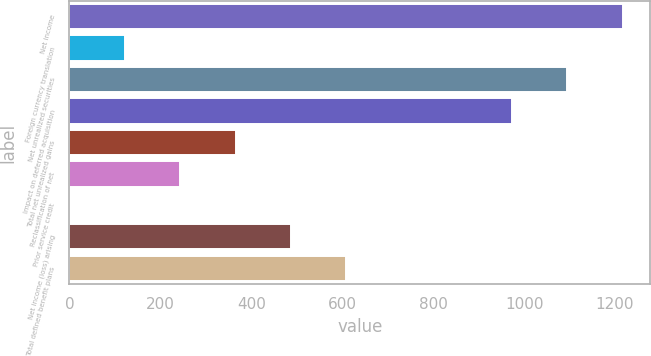Convert chart to OTSL. <chart><loc_0><loc_0><loc_500><loc_500><bar_chart><fcel>Net income<fcel>Foreign currency translation<fcel>Net unrealized securities<fcel>Impact on deferred acquisition<fcel>Total net unrealized gains<fcel>Reclassification of net<fcel>Prior service credit<fcel>Net income (loss) arising<fcel>Total defined benefit plans<nl><fcel>1217<fcel>122.6<fcel>1095.4<fcel>973.8<fcel>365.8<fcel>244.2<fcel>1<fcel>487.4<fcel>609<nl></chart> 